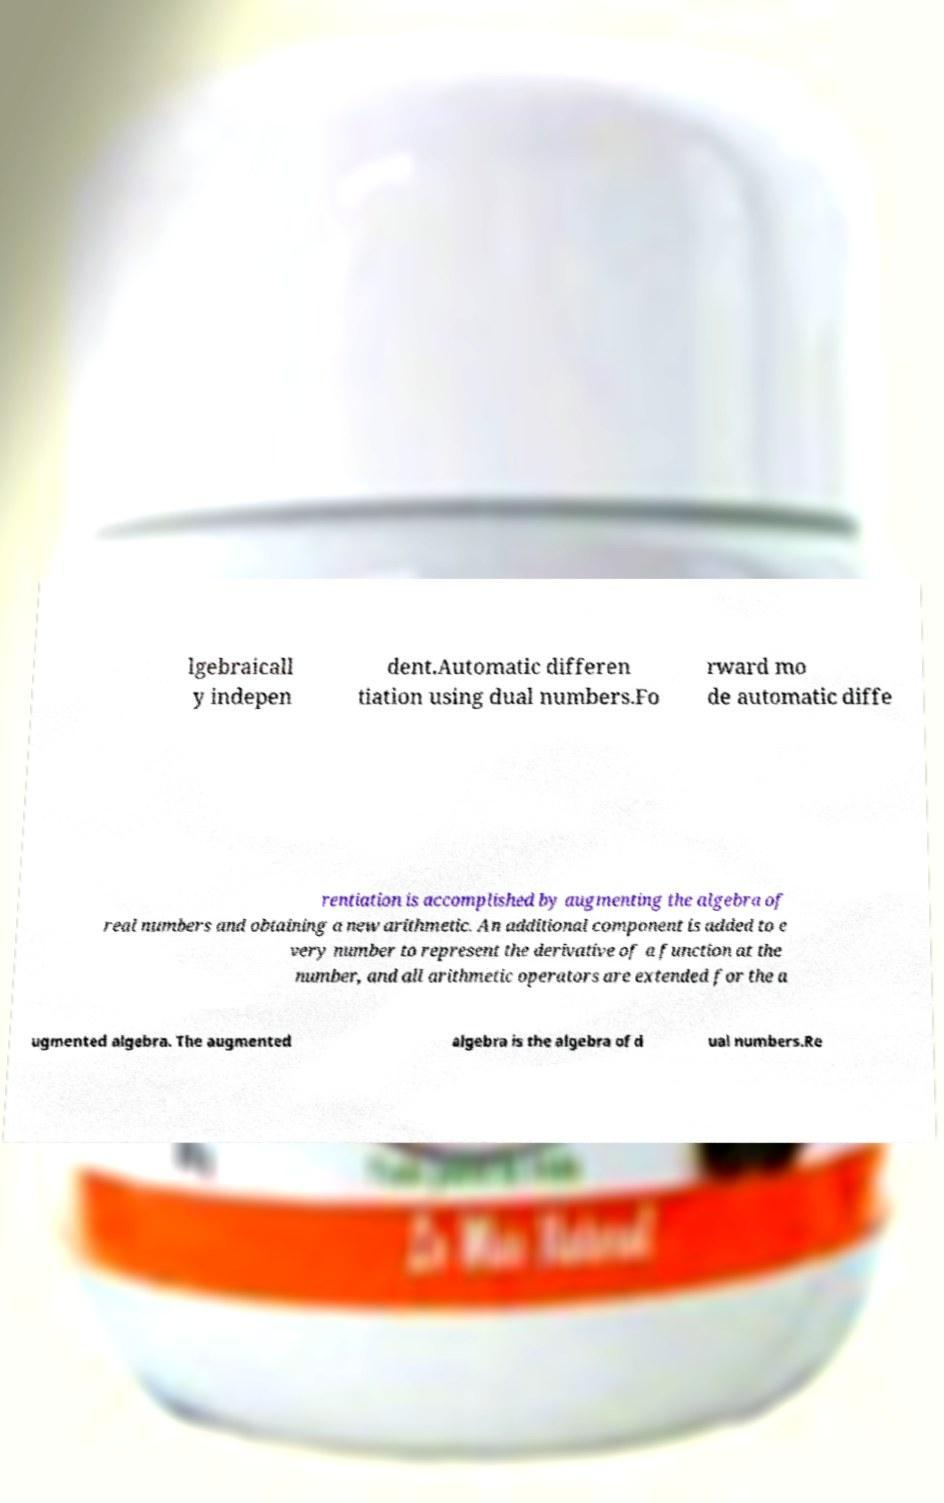Can you accurately transcribe the text from the provided image for me? lgebraicall y indepen dent.Automatic differen tiation using dual numbers.Fo rward mo de automatic diffe rentiation is accomplished by augmenting the algebra of real numbers and obtaining a new arithmetic. An additional component is added to e very number to represent the derivative of a function at the number, and all arithmetic operators are extended for the a ugmented algebra. The augmented algebra is the algebra of d ual numbers.Re 